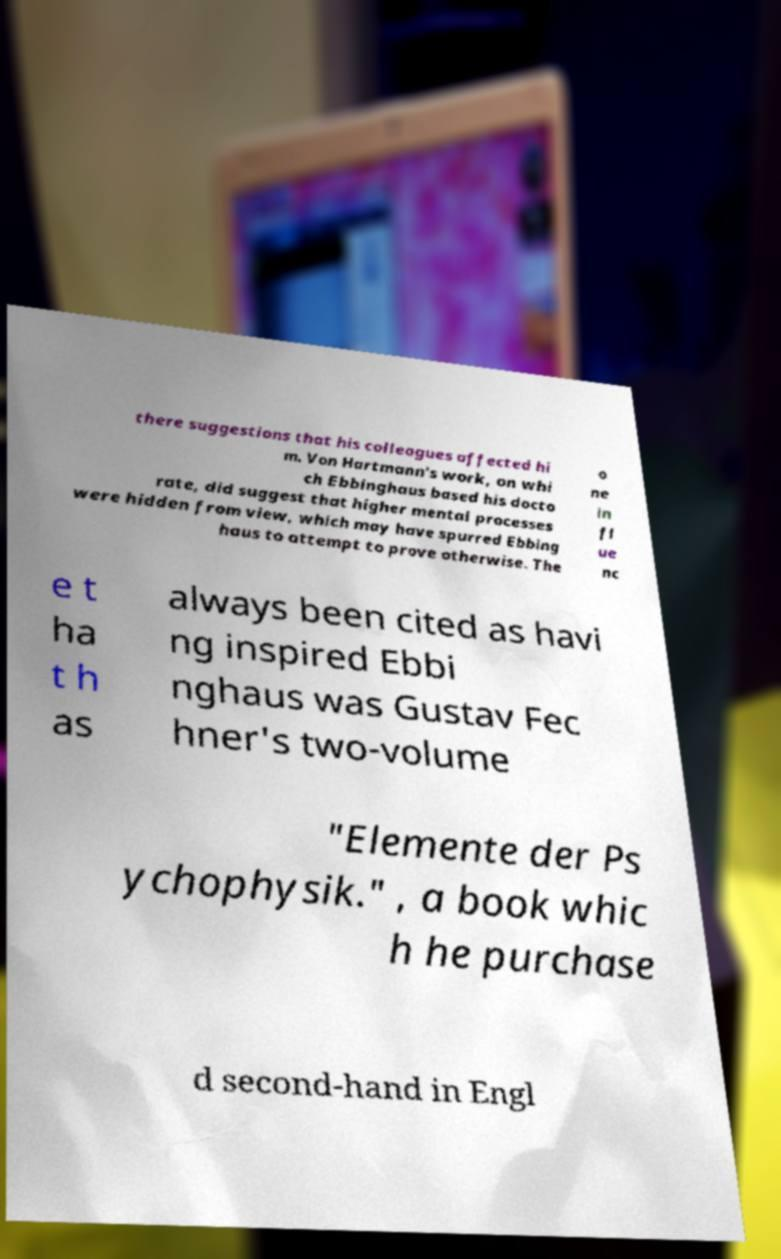Could you extract and type out the text from this image? there suggestions that his colleagues affected hi m. Von Hartmann's work, on whi ch Ebbinghaus based his docto rate, did suggest that higher mental processes were hidden from view, which may have spurred Ebbing haus to attempt to prove otherwise. The o ne in fl ue nc e t ha t h as always been cited as havi ng inspired Ebbi nghaus was Gustav Fec hner's two-volume "Elemente der Ps ychophysik." , a book whic h he purchase d second-hand in Engl 